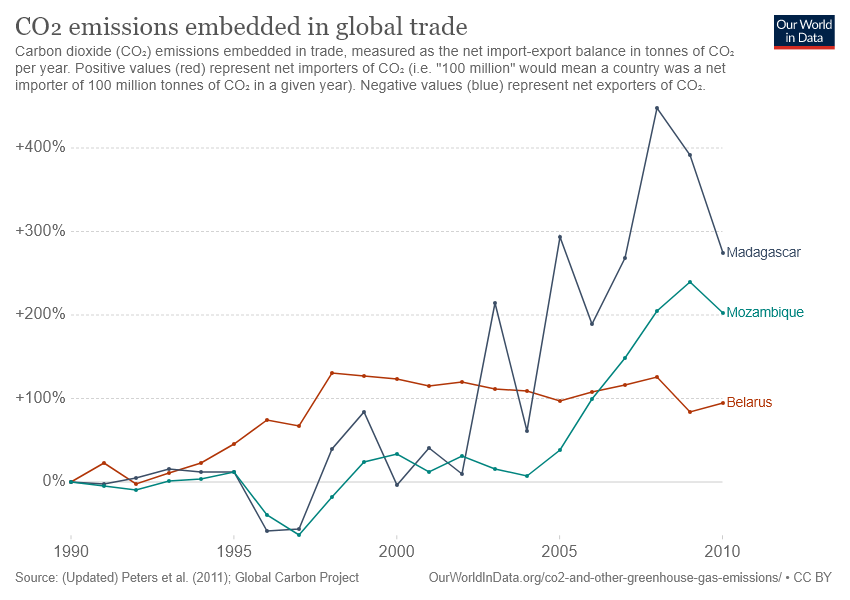Specify some key components in this picture. Belarus is represented by the red color line. The period during which CO2 emissions from global trade were highest in Madagascar was between 2005 and 2010. 